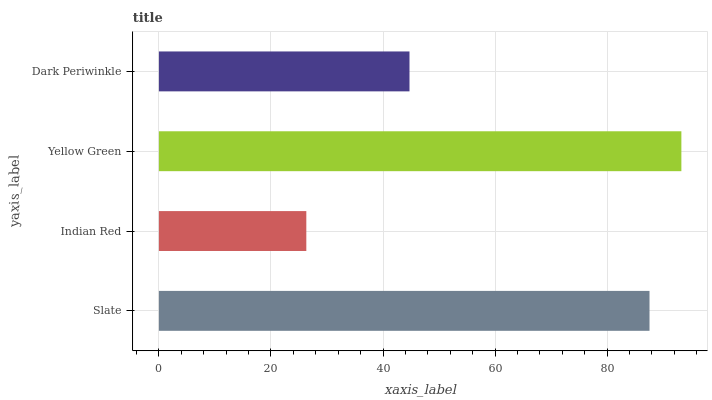Is Indian Red the minimum?
Answer yes or no. Yes. Is Yellow Green the maximum?
Answer yes or no. Yes. Is Yellow Green the minimum?
Answer yes or no. No. Is Indian Red the maximum?
Answer yes or no. No. Is Yellow Green greater than Indian Red?
Answer yes or no. Yes. Is Indian Red less than Yellow Green?
Answer yes or no. Yes. Is Indian Red greater than Yellow Green?
Answer yes or no. No. Is Yellow Green less than Indian Red?
Answer yes or no. No. Is Slate the high median?
Answer yes or no. Yes. Is Dark Periwinkle the low median?
Answer yes or no. Yes. Is Indian Red the high median?
Answer yes or no. No. Is Slate the low median?
Answer yes or no. No. 